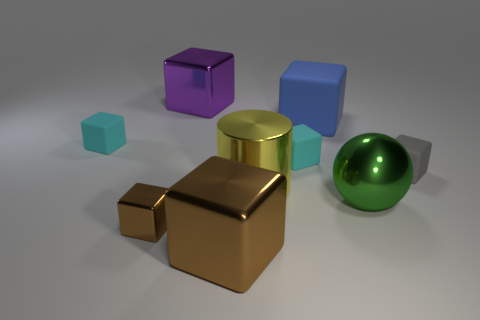Is there any other thing that has the same shape as the green metallic object?
Make the answer very short. No. What number of other things are there of the same color as the small metal cube?
Make the answer very short. 1. Do the shiny cube on the right side of the purple block and the small metal thing have the same color?
Provide a short and direct response. Yes. Do the big sphere and the brown thing that is right of the tiny brown thing have the same material?
Offer a very short reply. Yes. There is a blue object that is made of the same material as the tiny gray cube; what is its size?
Give a very brief answer. Large. Is the number of tiny matte blocks to the right of the big green sphere greater than the number of big rubber cubes on the right side of the big blue rubber thing?
Your answer should be compact. Yes. Are there any other tiny things that have the same shape as the blue thing?
Ensure brevity in your answer.  Yes. Do the cube that is on the right side of the blue block and the tiny metallic cube have the same size?
Keep it short and to the point. Yes. Are there any tiny yellow matte cylinders?
Make the answer very short. No. How many objects are big things that are in front of the blue rubber block or small yellow matte blocks?
Provide a succinct answer. 3. 